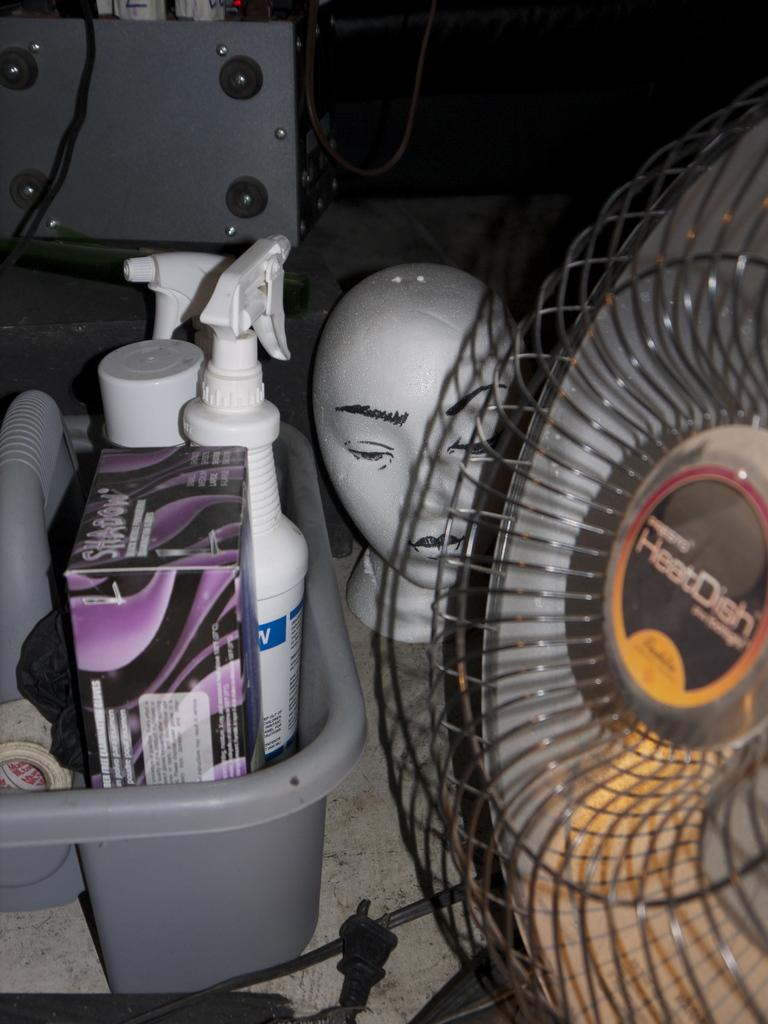What type of appliance is visible in the image? There is a table fan in the image. What else can be seen in the image besides the table fan? There is a wire, a tray with spray bottles, a box, a mannequin head, and a black object with screws in the image. Where are these objects placed? The objects are placed on a table. What type of disgusting creature can be seen crawling on the mannequin head in the image? There are no creatures, disgusting or otherwise, present in the image. 